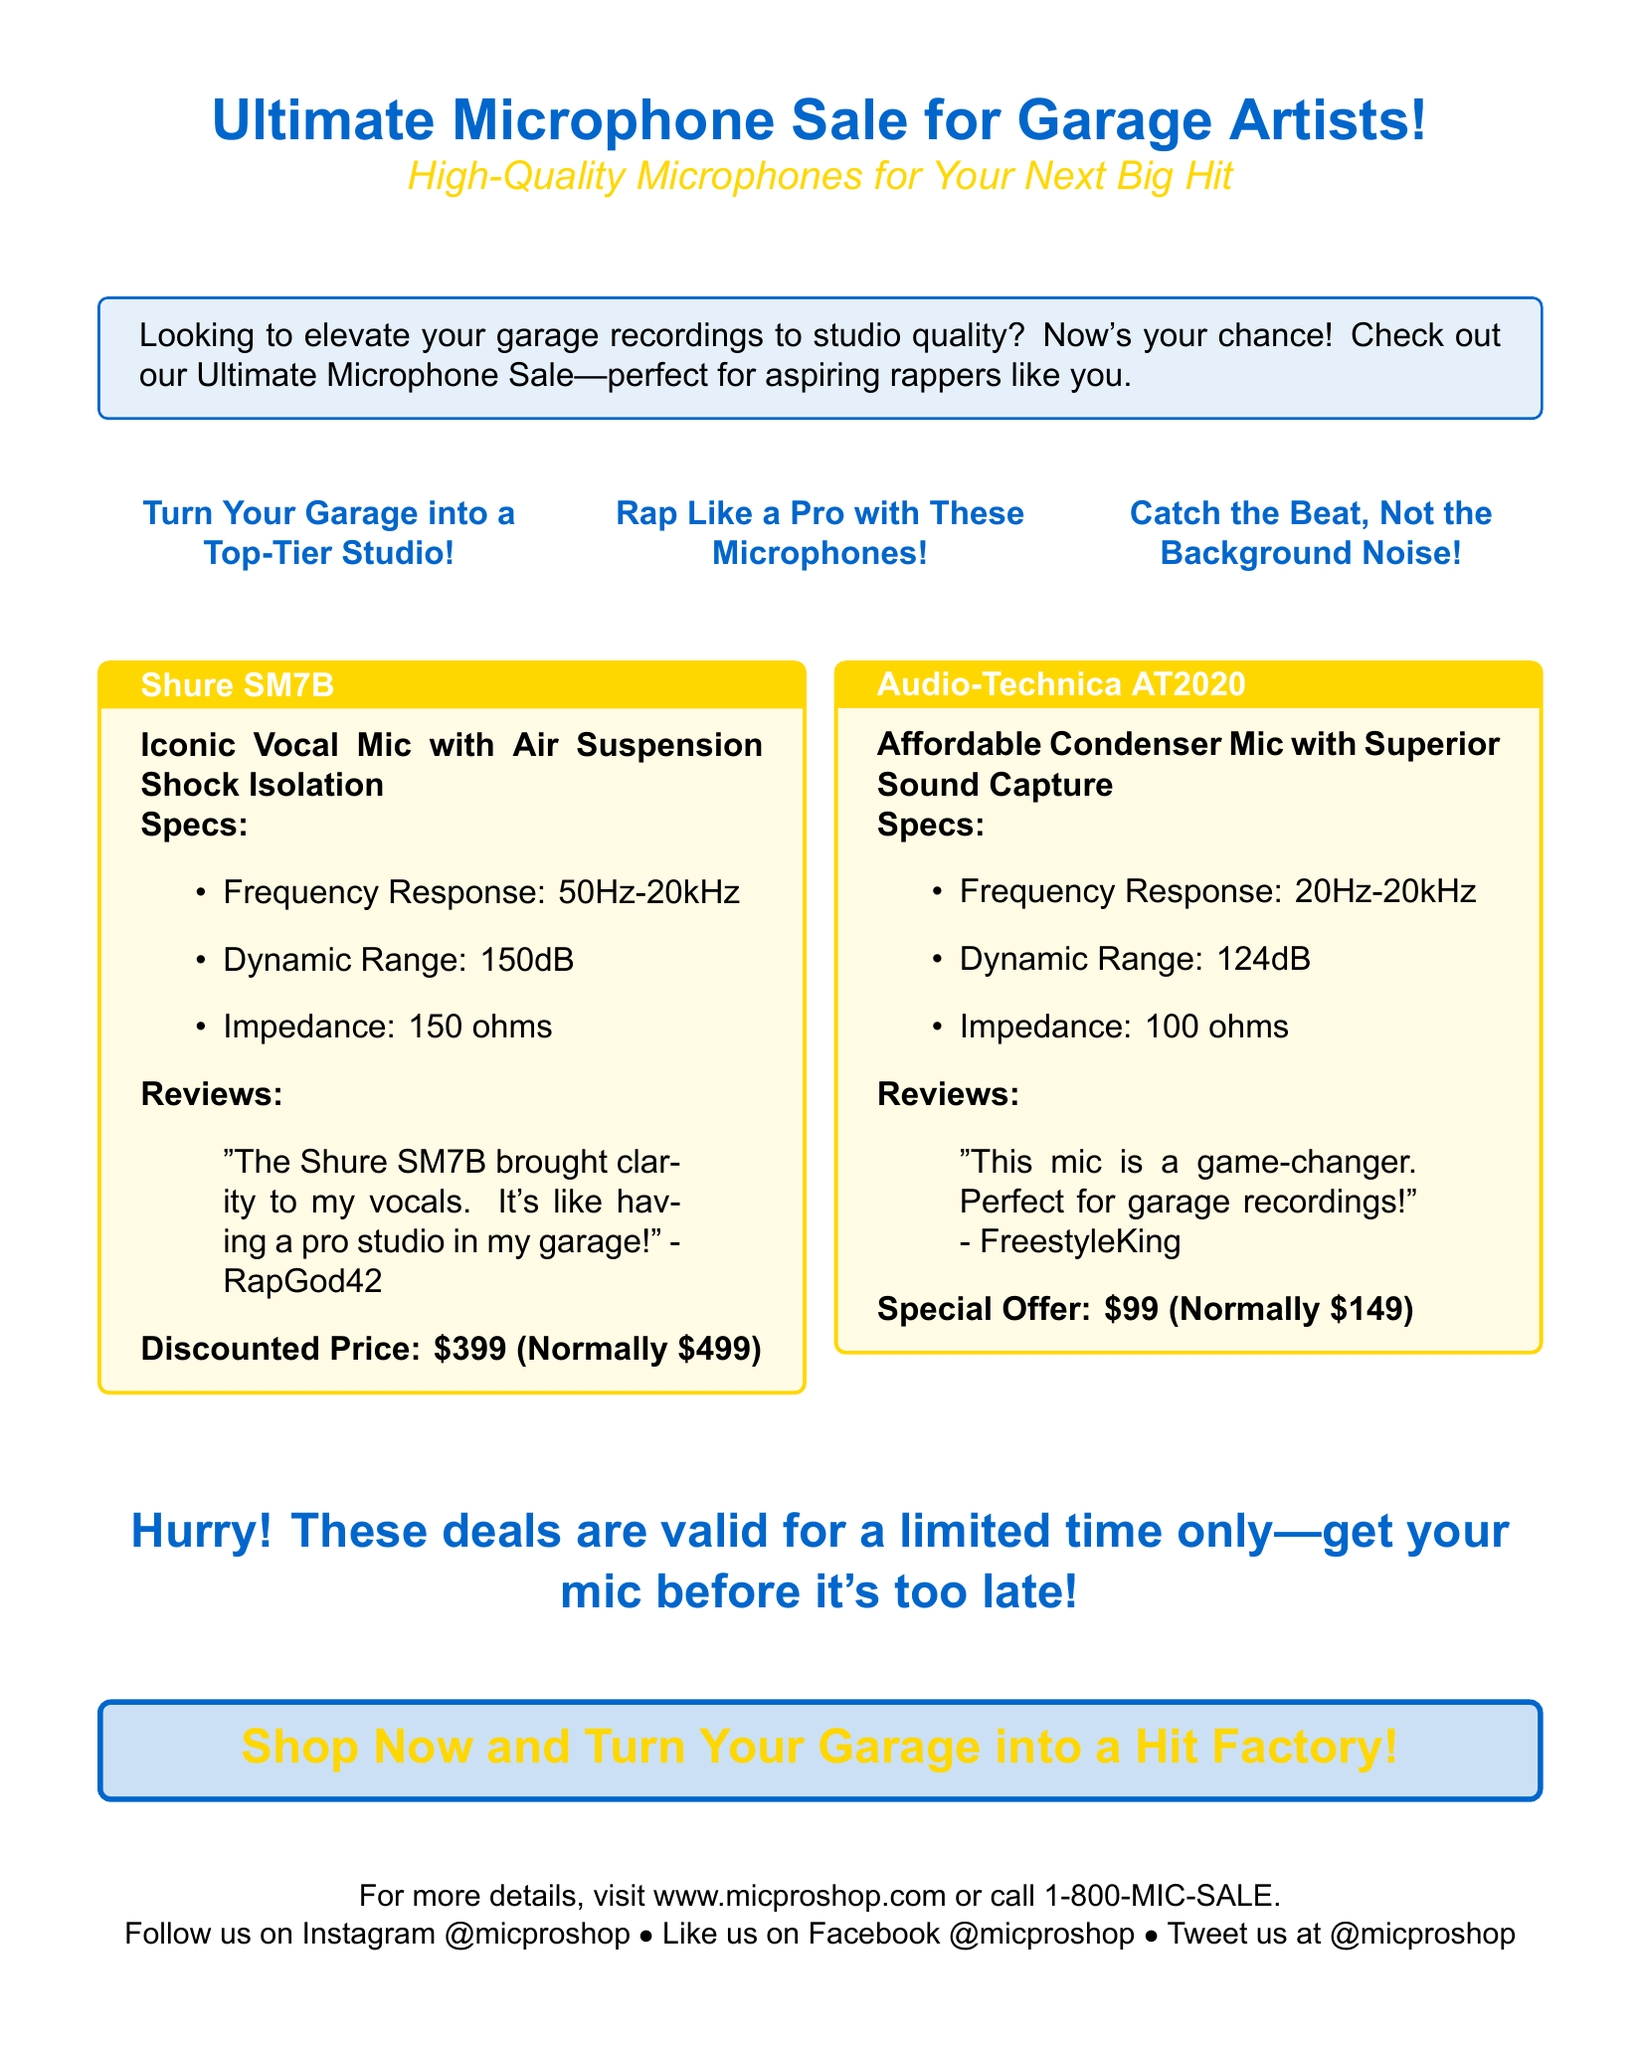What is the name of the advertisement? The name of the advertisement is clearly stated at the top and emphasizes the microphone sale for garage artists.
Answer: Ultimate Microphone Sale for Garage Artists! What is the discounted price of the Shure SM7B? The advertisement specifies the discounted price of the Shure SM7B along with its normal price.
Answer: $399 What is the frequency response of the Audio-Technica AT2020? The frequency response is listed in the specifications section for the Audio-Technica AT2020.
Answer: 20Hz-20kHz Who provided the review for the Shure SM7B? The review for the Shure SM7B is quoted in the document and attributes the review to a specific user.
Answer: RapGod42 What color is the background of the tcolorbox for the Audio-Technica AT2020? The background color of the tcolorbox for the Audio-Technica AT2020 is described in the document.
Answer: rapgold!10 What type of microphone is the Shure SM7B? The document describes the Shure SM7B and its special features in the product description.
Answer: Vocal Mic What unique feature does the Audio-Technica AT2020 offer? The advertisement highlights this aspect in the description of the Audio-Technica AT2020.
Answer: Superior Sound Capture What is the urgency of the sale? The document indicates a time-sensitive nature of the offers.
Answer: Limited time only What is the main target audience of this advertisement? The content of the advertisement hints clearly at who it is meant for.
Answer: Garage Artists 